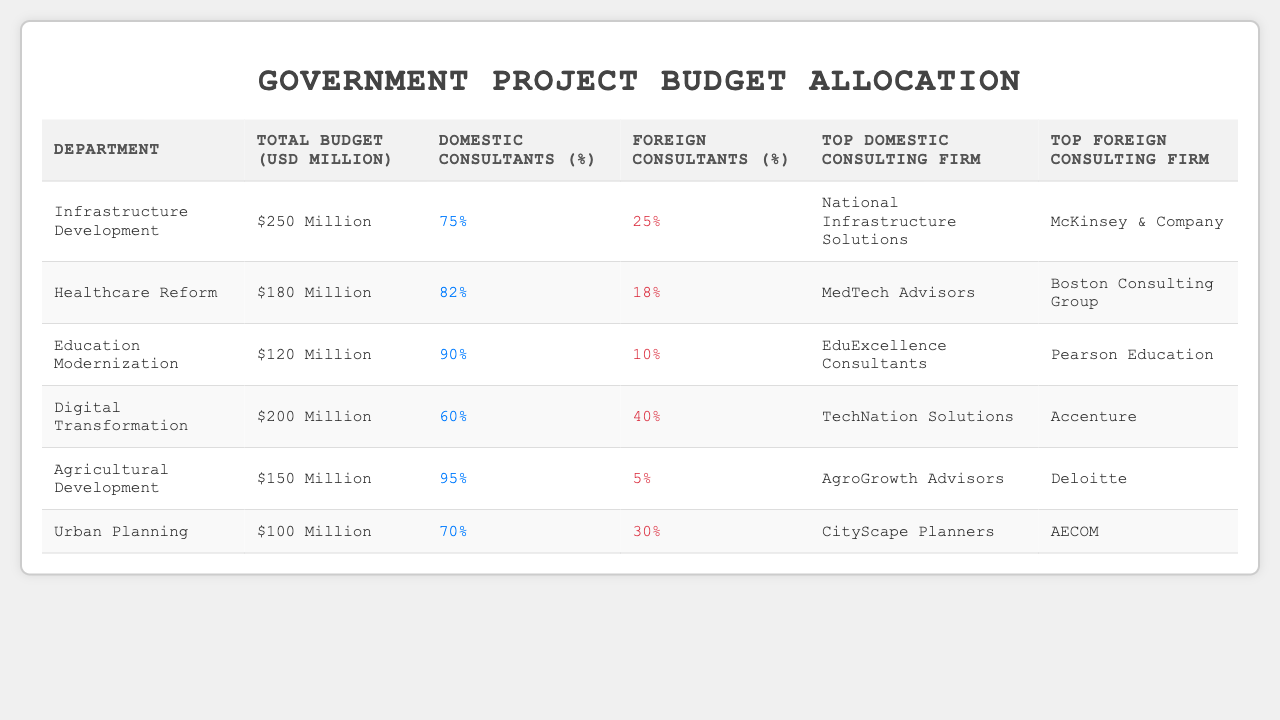What is the total budget for the Healthcare Reform department? Looking at the table, the Total Budget for Healthcare Reform is listed as 180 USD Million.
Answer: 180 USD Million Which department has the highest percentage of domestic consultants? The percentage of domestic consultants is listed for each department. Agricultural Development has the highest at 95%.
Answer: Agricultural Development What is the Total Budget for the Digital Transformation department? According to the table, the Total Budget for Digital Transformation is 200 USD Million.
Answer: 200 USD Million What percentage of consultants in the Education Modernization department are foreign? The table indicates that Education Modernization has 10% of consultants who are foreign.
Answer: 10% Which department has the lowest budget allocation? The budgets listed show that Urban Planning has the lowest Total Budget at 100 USD Million.
Answer: Urban Planning What is the difference in consultant percentages between Domestic and Foreign for the Infrastructure Development department? For Infrastructure Development, there are 75% domestic and 25% foreign consultants. The difference is 75% - 25% = 50%.
Answer: 50% Is McKinsey & Company the top domestic consulting firm for any department? The table lists McKinsey & Company as the top foreign consulting firm for Infrastructure Development, confirming it is not a domestic firm.
Answer: No If we sum the total budgets of all departments, what is the total? By adding all departments' Total Budgets: 250 + 180 + 120 + 200 + 150 + 100 = 1,100 million USD.
Answer: 1,100 USD Million What percentage of consultants are domestic in the Urban Planning department? The table shows that Urban Planning has 70% domestic consultants.
Answer: 70% Which consulting firms are listed as top domestic and foreign for the Agricultural Development department? According to the table, the top domestic consulting firm is AgroGrowth Advisors and the top foreign consulting firm is Deloitte for Agricultural Development.
Answer: AgroGrowth Advisors and Deloitte What is the average percentage of foreign consultants across all departments? Adding the foreign consultant percentages: 25 + 18 + 10 + 40 + 5 + 30 = 128%. There are 6 departments, so the average is 128% / 6 = 21.33%.
Answer: 21.33% In which department does Accenture serve as the top foreign consulting firm? According to the table, Accenture is indicated as the top foreign consulting firm for the Digital Transformation department.
Answer: Digital Transformation 